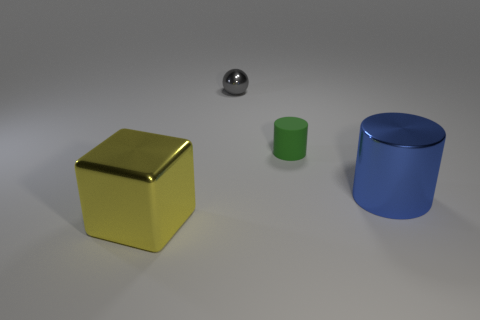Add 2 metallic objects. How many objects exist? 6 Subtract all spheres. How many objects are left? 3 Add 4 tiny shiny balls. How many tiny shiny balls exist? 5 Subtract 0 cyan cylinders. How many objects are left? 4 Subtract all rubber things. Subtract all small gray matte balls. How many objects are left? 3 Add 1 small matte cylinders. How many small matte cylinders are left? 2 